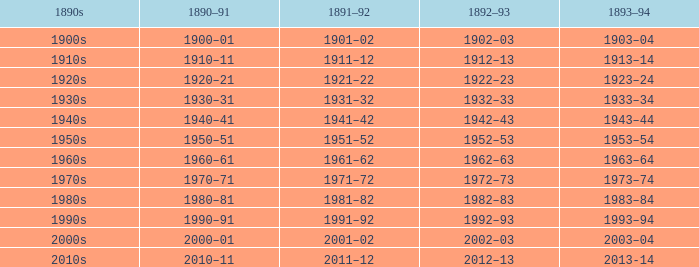What is the year from 1892-93 that has the 1890s to the 1940s? 1942–43. 